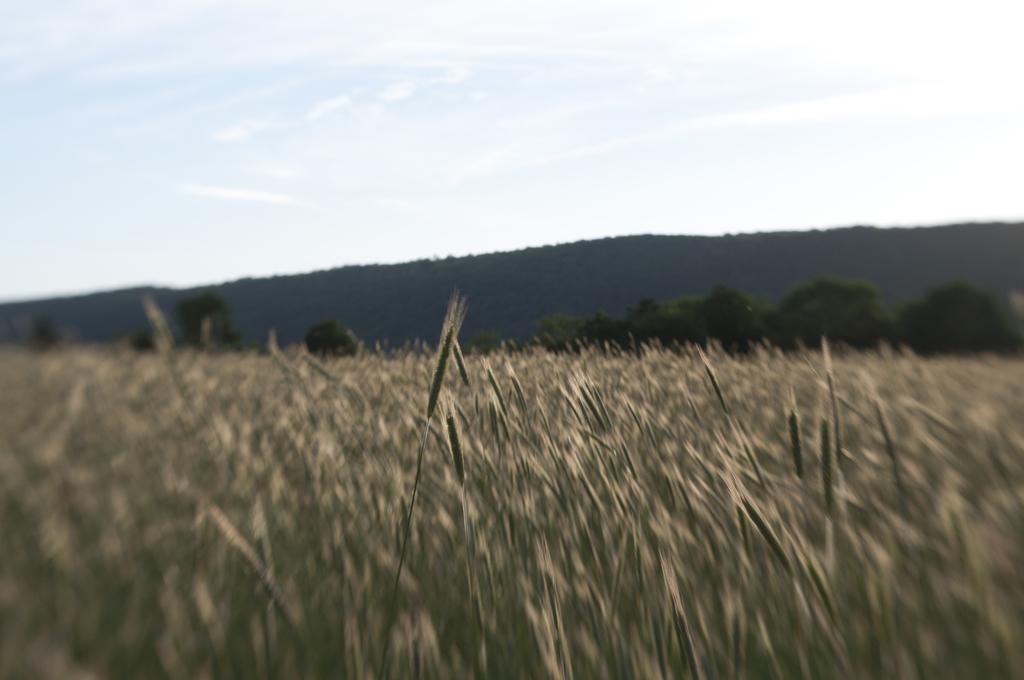Could you give a brief overview of what you see in this image? In this image in front there is a crop. In the background of the image there are trees, mountains and sky. 